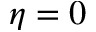Convert formula to latex. <formula><loc_0><loc_0><loc_500><loc_500>\eta = 0</formula> 